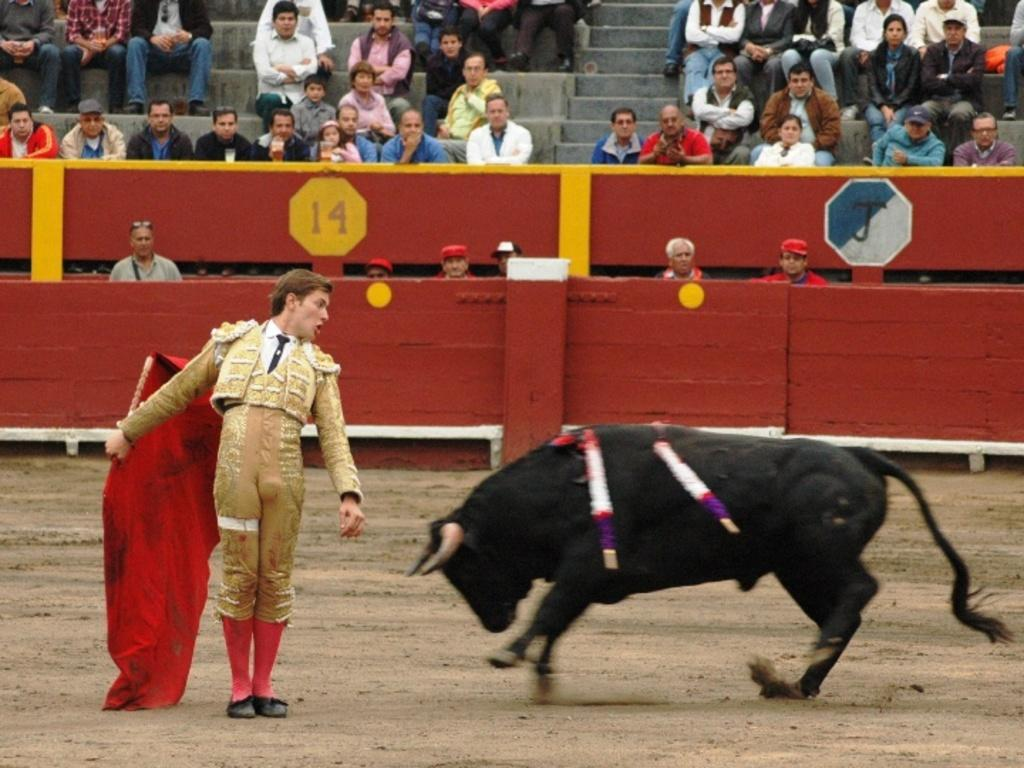Who is present in the image? There is a man in the image. What is the man holding in the image? The man is holding a red cloth. What does the red cloth represent? The red cloth represents a bull. What are the other people in the image doing? There are people sitting in the image. What type of furniture can be seen in the image? There is no furniture present in the image. 